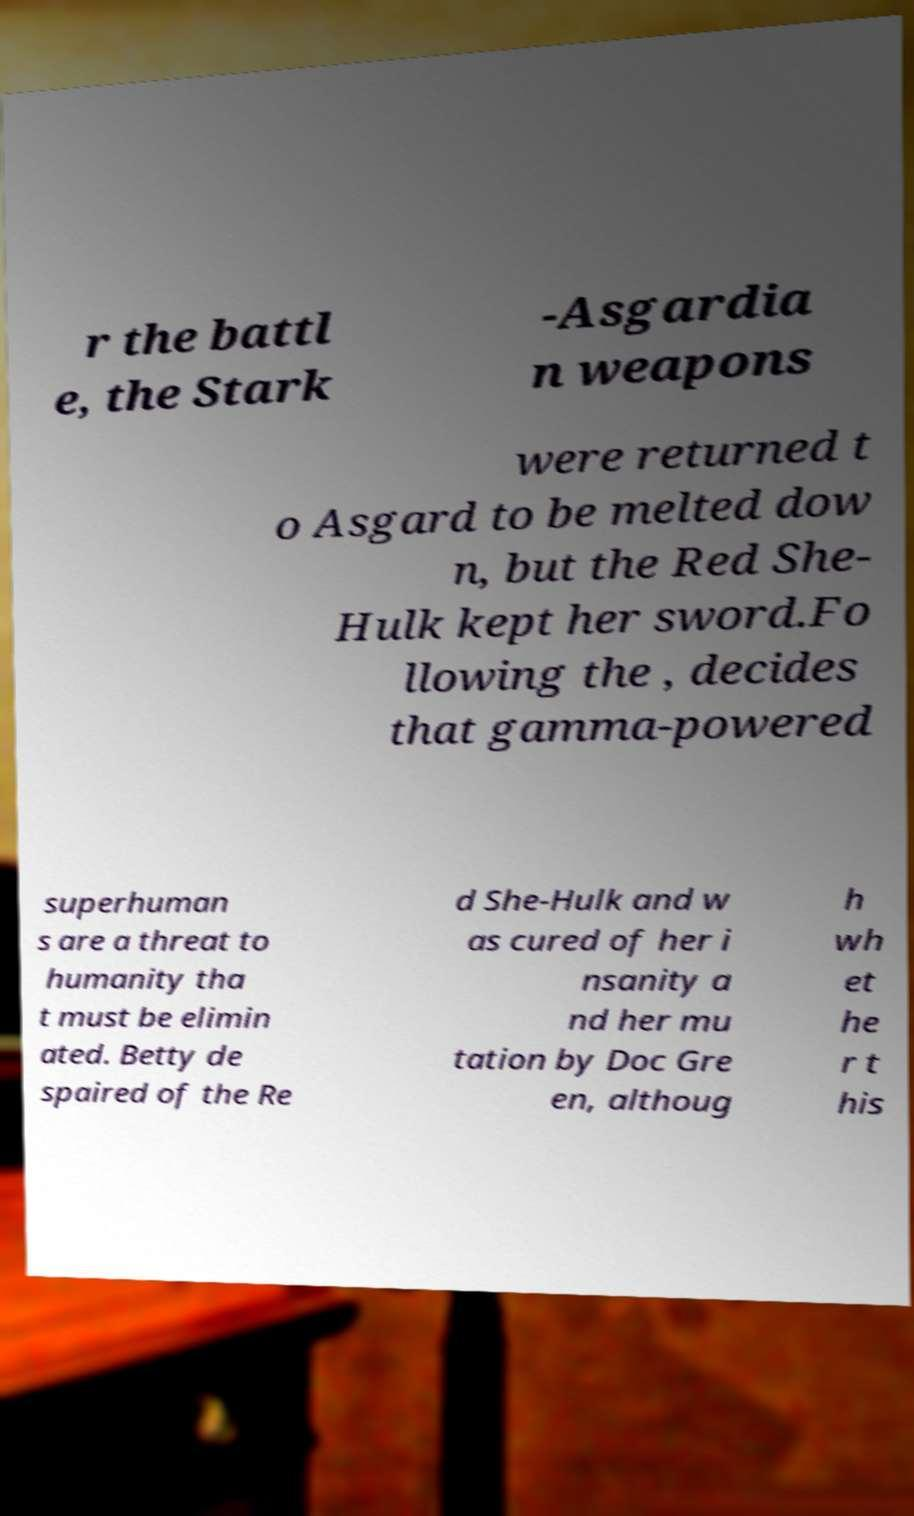Can you accurately transcribe the text from the provided image for me? r the battl e, the Stark -Asgardia n weapons were returned t o Asgard to be melted dow n, but the Red She- Hulk kept her sword.Fo llowing the , decides that gamma-powered superhuman s are a threat to humanity tha t must be elimin ated. Betty de spaired of the Re d She-Hulk and w as cured of her i nsanity a nd her mu tation by Doc Gre en, althoug h wh et he r t his 